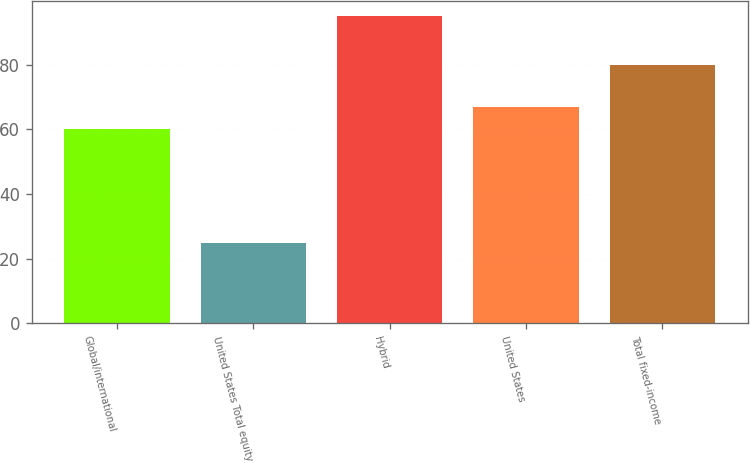Convert chart to OTSL. <chart><loc_0><loc_0><loc_500><loc_500><bar_chart><fcel>Global/international<fcel>United States Total equity<fcel>Hybrid<fcel>United States<fcel>Total fixed-income<nl><fcel>60<fcel>25<fcel>95<fcel>67<fcel>80<nl></chart> 